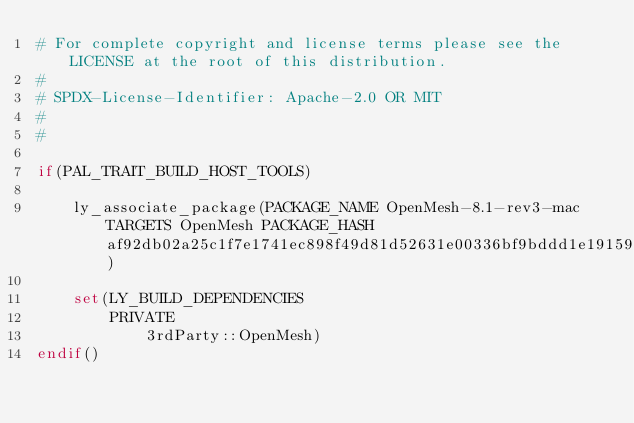Convert code to text. <code><loc_0><loc_0><loc_500><loc_500><_CMake_># For complete copyright and license terms please see the LICENSE at the root of this distribution.
#
# SPDX-License-Identifier: Apache-2.0 OR MIT
#
#

if(PAL_TRAIT_BUILD_HOST_TOOLS)

    ly_associate_package(PACKAGE_NAME OpenMesh-8.1-rev3-mac TARGETS OpenMesh PACKAGE_HASH af92db02a25c1f7e1741ec898f49d81d52631e00336bf9bddd1e191590063c2f)

    set(LY_BUILD_DEPENDENCIES
        PRIVATE
            3rdParty::OpenMesh)
endif()
</code> 